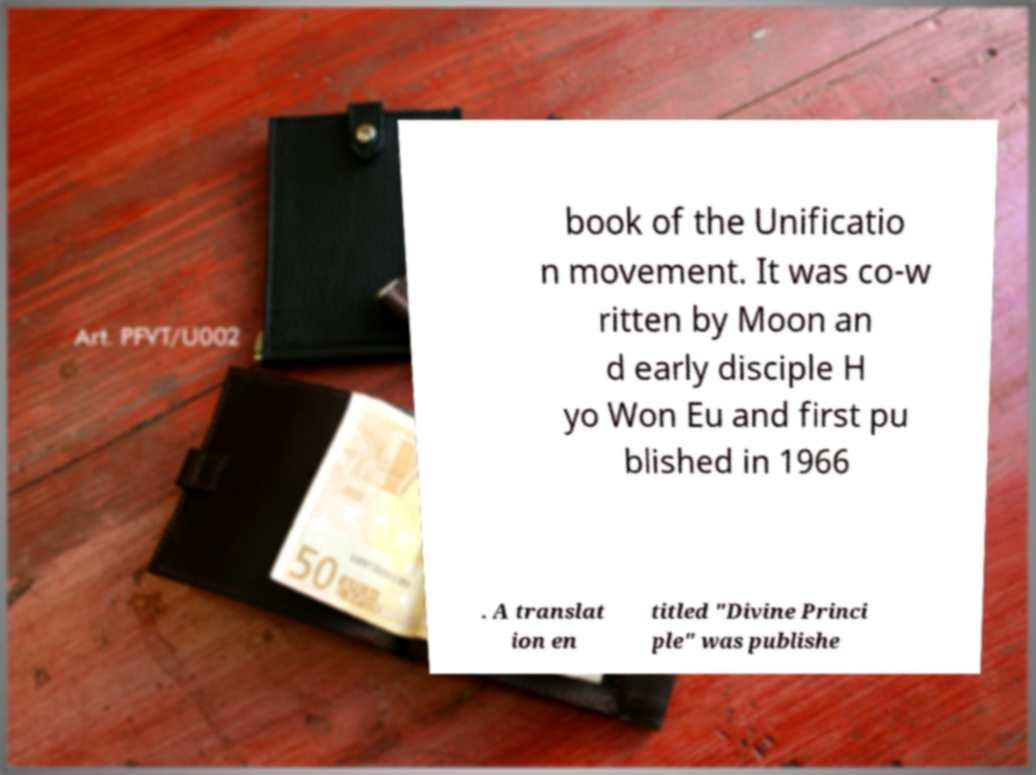Could you extract and type out the text from this image? book of the Unificatio n movement. It was co-w ritten by Moon an d early disciple H yo Won Eu and first pu blished in 1966 . A translat ion en titled "Divine Princi ple" was publishe 